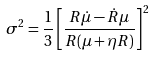<formula> <loc_0><loc_0><loc_500><loc_500>\sigma ^ { 2 } = \frac { 1 } { 3 } \left [ \frac { R \dot { \mu } - \dot { R } \mu } { R ( \mu + \eta R ) } \right ] ^ { 2 }</formula> 